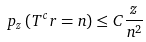<formula> <loc_0><loc_0><loc_500><loc_500>\ p _ { z } \left ( T ^ { c } r = n \right ) \leq C \frac { z } { n ^ { 2 } }</formula> 